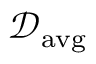Convert formula to latex. <formula><loc_0><loc_0><loc_500><loc_500>\mathcal { D } _ { a v g }</formula> 